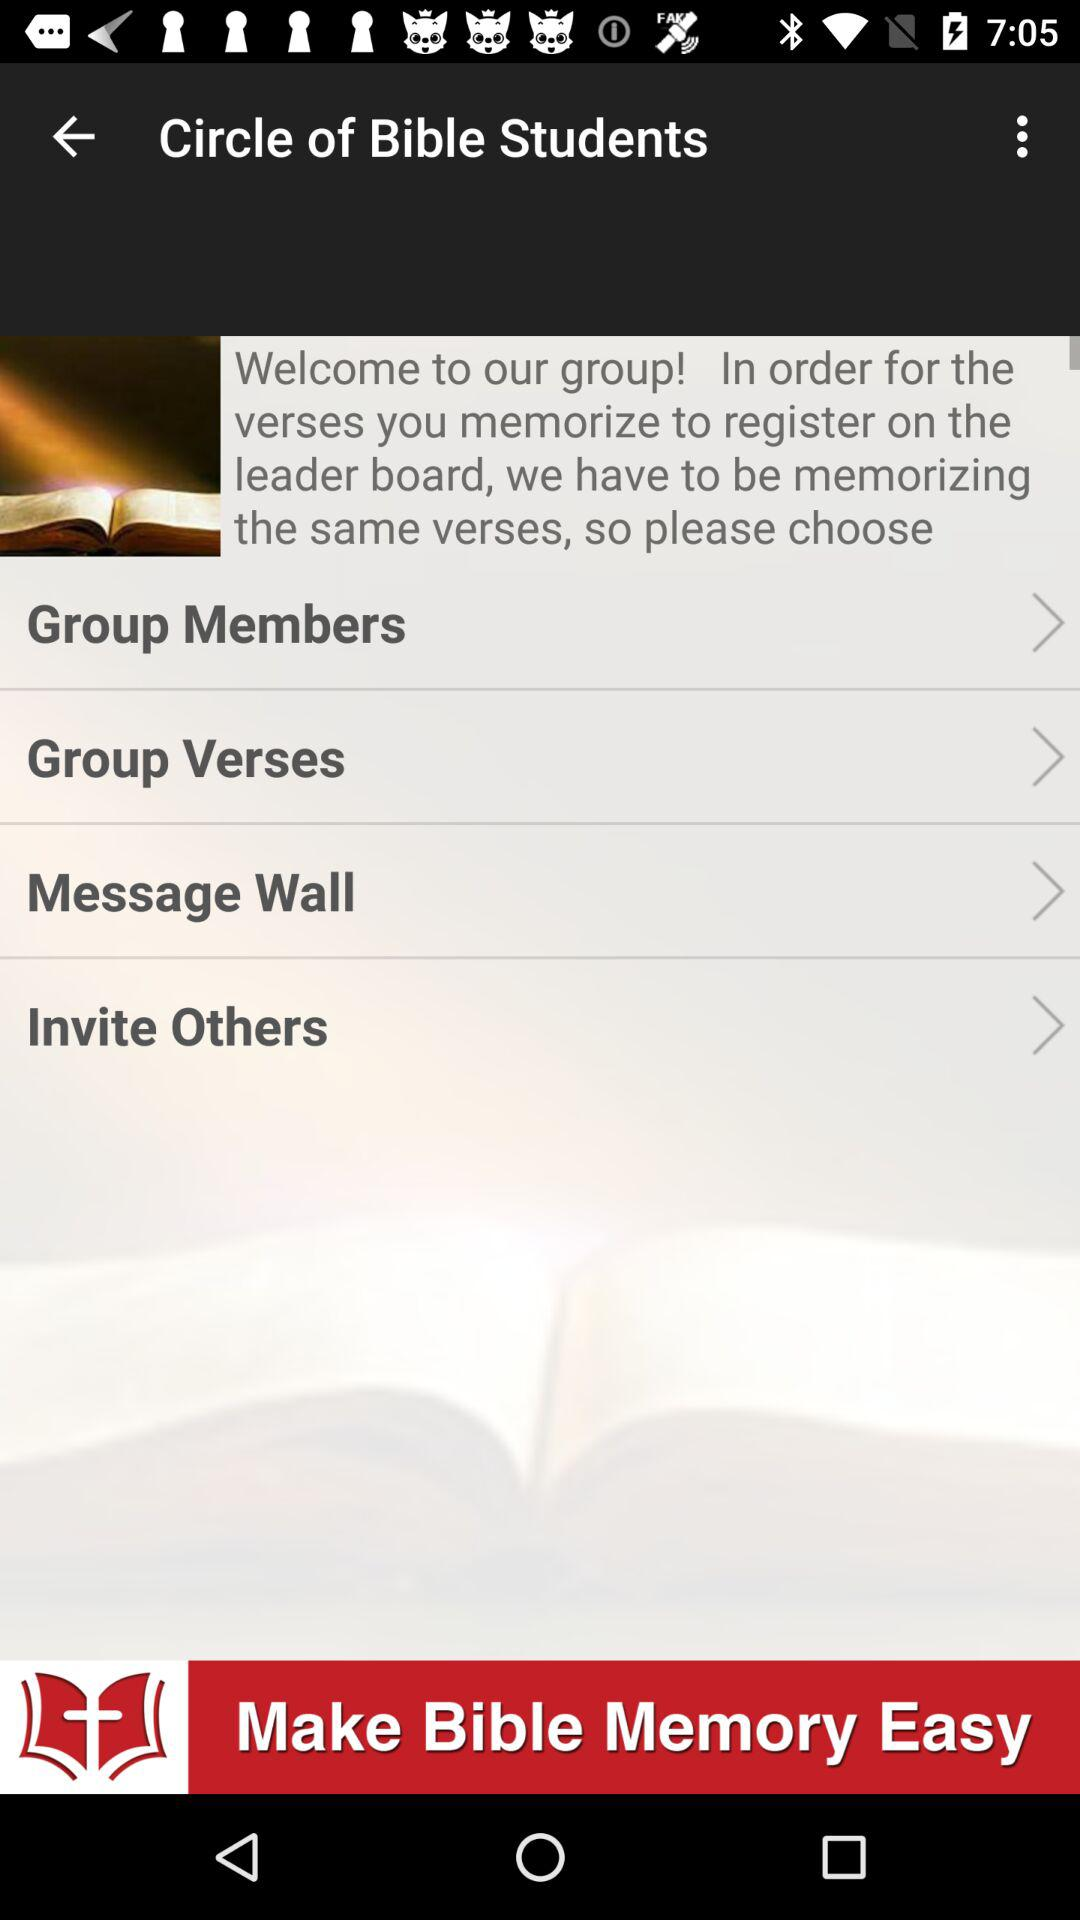What is the app name?
When the provided information is insufficient, respond with <no answer>. <no answer> 